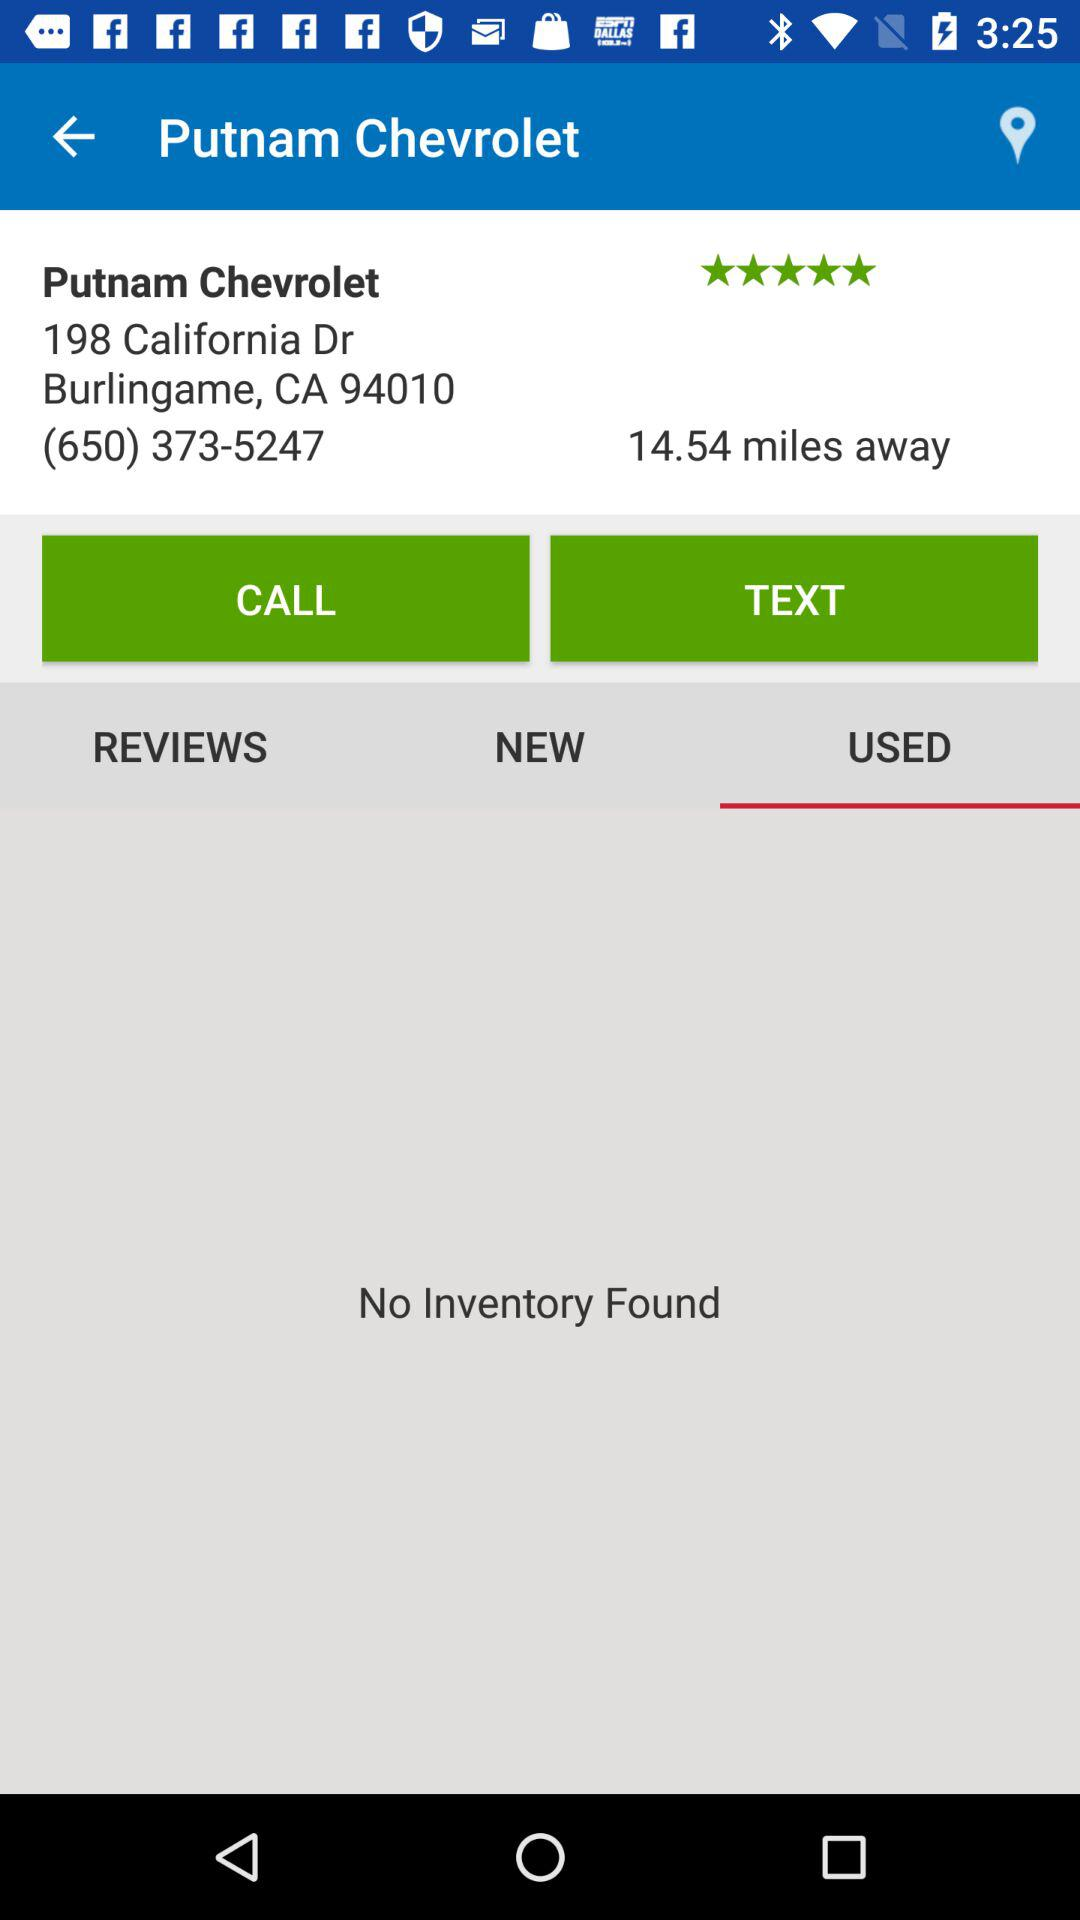Is there any inventory found? There is no inventory found. 